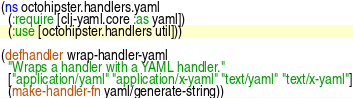<code> <loc_0><loc_0><loc_500><loc_500><_Clojure_>(ns octohipster.handlers.yaml
  (:require [clj-yaml.core :as yaml])
  (:use [octohipster.handlers util]))

(defhandler wrap-handler-yaml
  "Wraps a handler with a YAML handler."
  ["application/yaml" "application/x-yaml" "text/yaml" "text/x-yaml"]
  (make-handler-fn yaml/generate-string))
</code> 